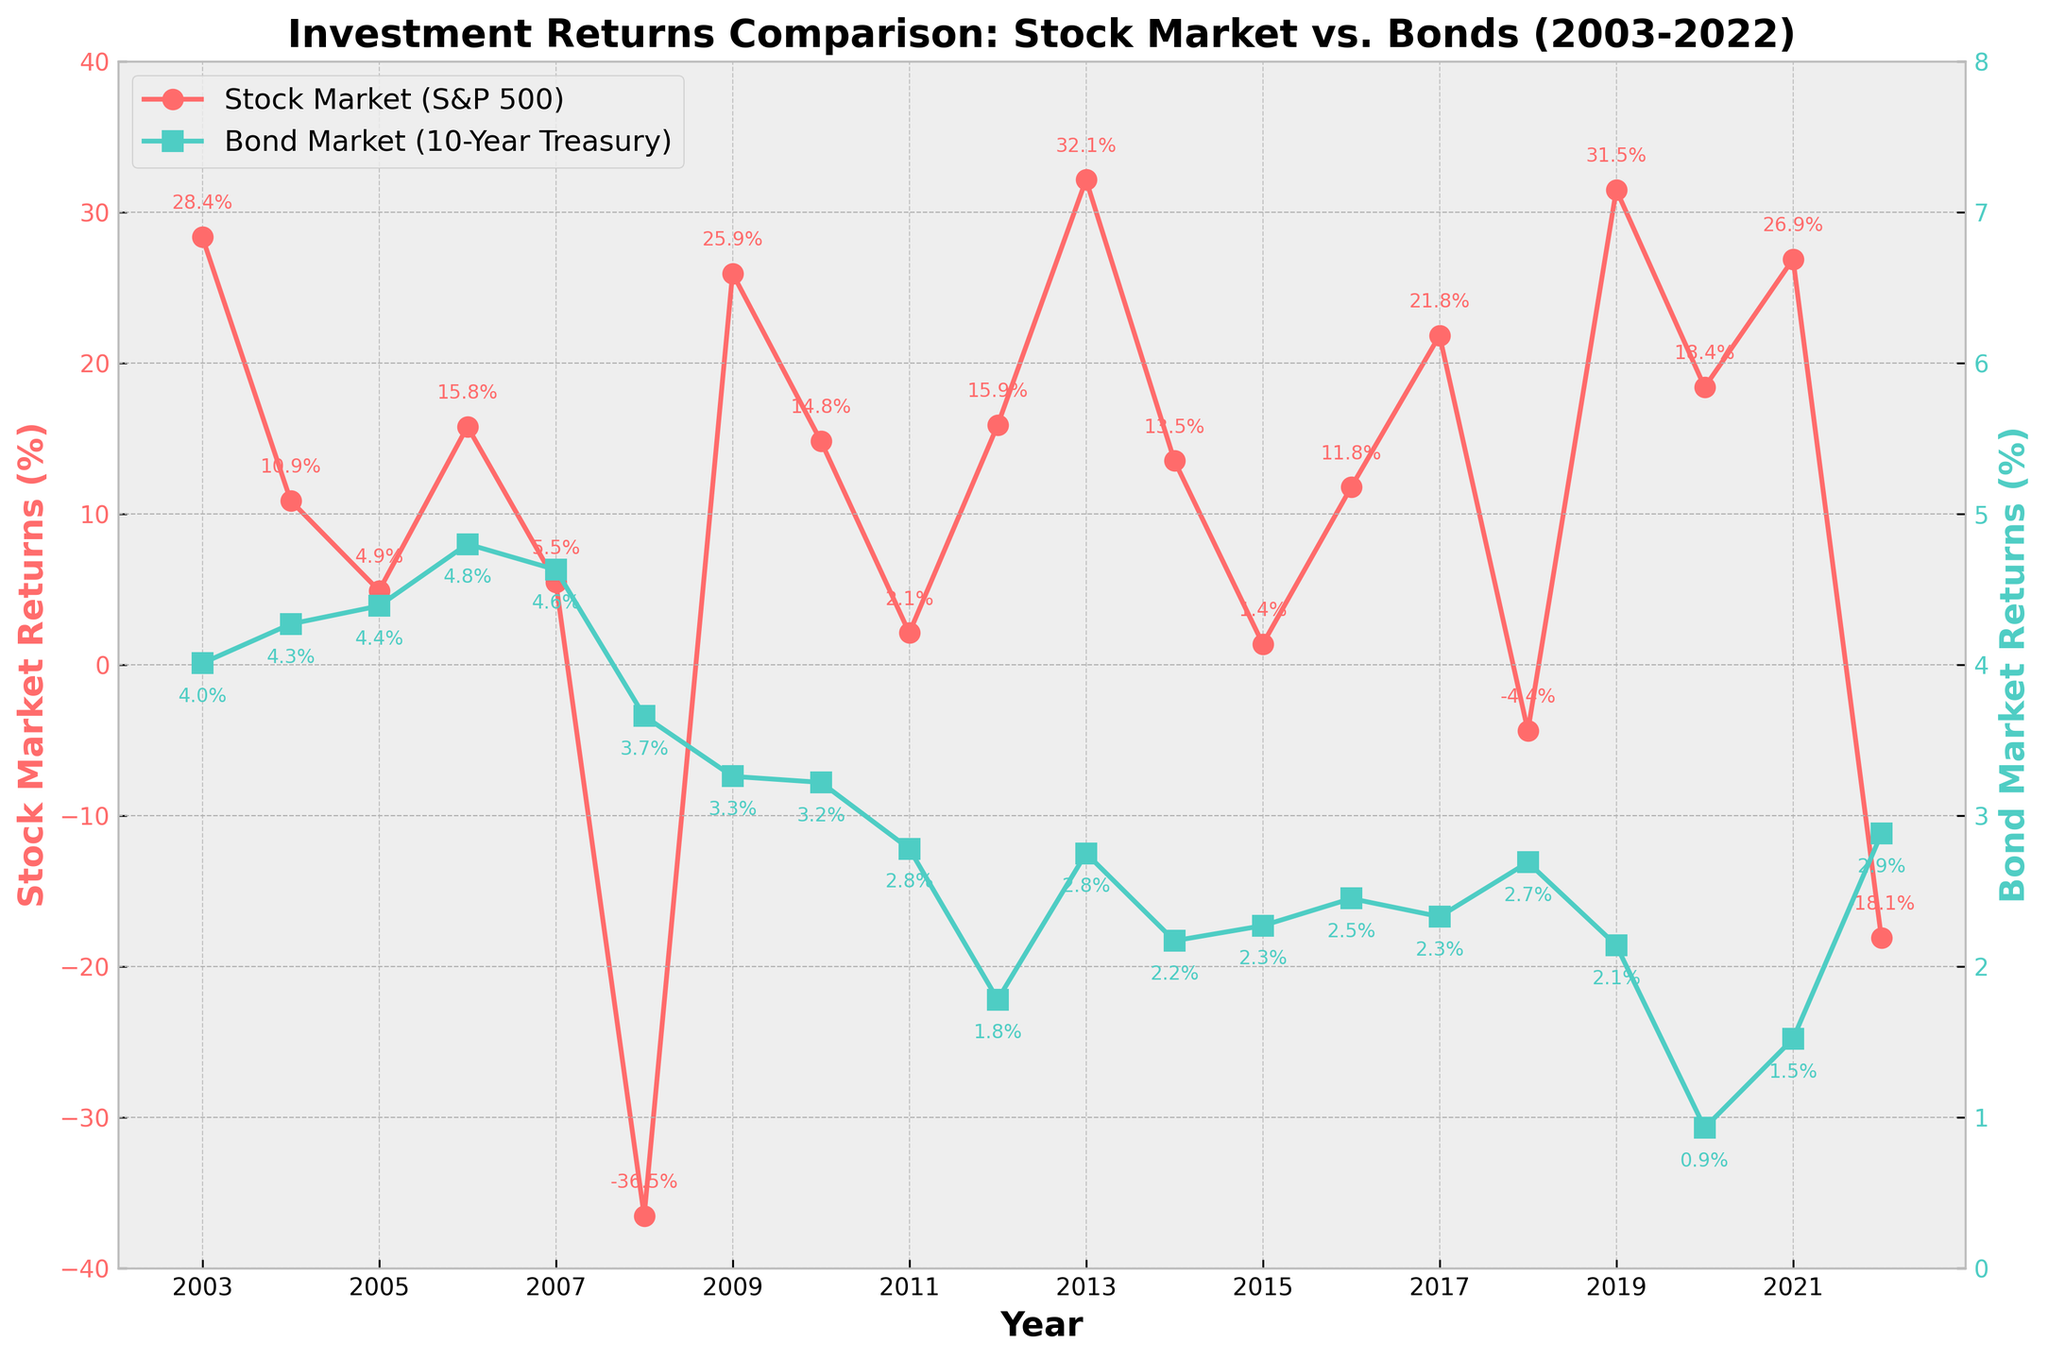What is the title of the figure? The title is typically at the top of a plot and is usually descriptive of the content displayed. In this case, it mentions the comparison of investment returns.
Answer: Investment Returns Comparison: Stock Market vs. Bonds (2003-2022) How many years of data are shown in the figure? Count the data points on the x-axis labeled as 'Year'. Each tick represents a year. Count them from 2003 to 2022.
Answer: 20 Which year had the highest stock market return, and what was the return percentage? Check the highest point on the stock market return line (indicated with red color and a circle marker). The corresponding year and value should represent the highest return.
Answer: 2013, 32.15% In which year did stock market returns drop the most, and what was the return percentage? Look for the lowest point in the red line (stock market returns). The corresponding year is the one with the most significant drop.
Answer: 2008, -36.55% How did bond market returns change from 2003 to 2022? Observe the green line (bond market returns) starting from 2003 to 2022. Describe the trend over the period.
Answer: They fluctuated with a slight decrease, ending at 2.88% in 2022 What was the average stock market return over the two decades? Add all stock market return values and divide by the number of years (20). Calculate the average.
Explanation: (28.36 + 10.88 + 4.91 + 15.79 + 5.49 - 36.55 + 25.94 + 14.82 + 2.11 + 15.89 + 32.15 + 13.52 + 1.38 + 11.77 + 21.83 - 4.38 + 31.49 + 18.4 + 26.89 - 18.11) / 20
Answer: 9.86% How many years did bond market returns outperform stock market returns? Count the years where the green line (bond market) is above the red line (stock market).
Answer: 3 years (2008, 2011, 2022) Which year shows the least return for bonds, and what was the return percentage? Identify the lowest point on the green line (bond market returns) and note the corresponding year and value.
Answer: 2020, 0.93% During which year(s) did both stock market and bond market returns experience positive growth? Look for years where both the red line (stock market) and green line (bond market) are above the x-axis (0%).
Answer: Multiple years: 2003, 2004, 2006, 2007, 2009, 2010, 2012, 2013, 2014, 2016, 2017, 2019, 2020, and 2021 Compare the overall trends of the stock market and bond market over the two decades. Observe the general direction and significant changes of both lines (stock market and bond market) from start to end.
Explanation: The stock market (red) shows higher volatility with large peaks and troughs, while the bond market (green) shows a less volatile trend with a slight decline overall.
Answer: Stock market is more volatile; bond market is more stable with a slight decline 